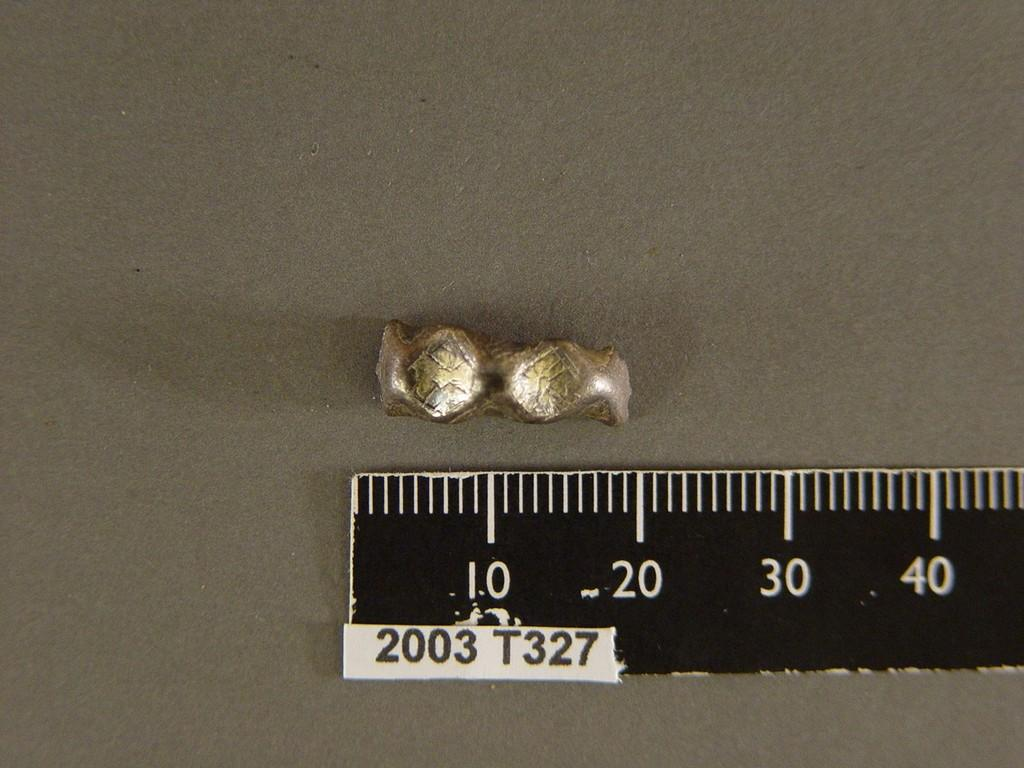<image>
Present a compact description of the photo's key features. The item shown beside the ruler measures about 20 millimetres. 